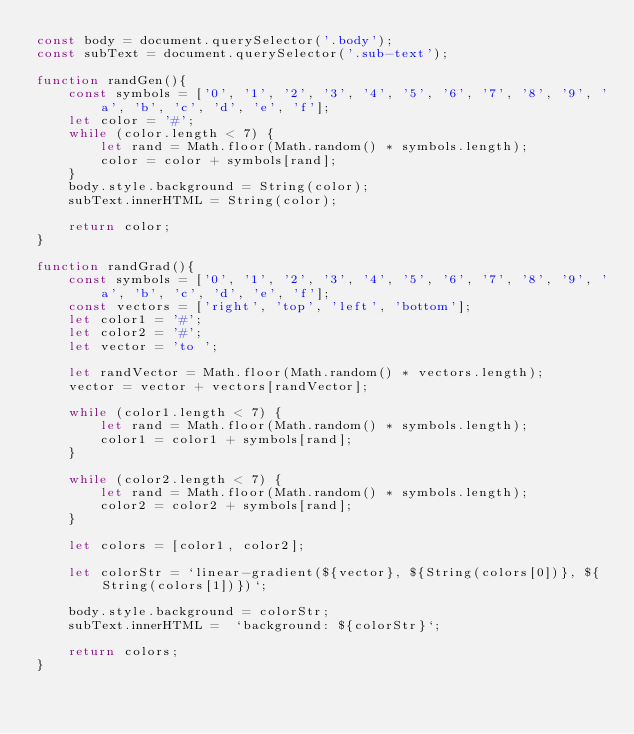<code> <loc_0><loc_0><loc_500><loc_500><_JavaScript_>const body = document.querySelector('.body');
const subText = document.querySelector('.sub-text');

function randGen(){
    const symbols = ['0', '1', '2', '3', '4', '5', '6', '7', '8', '9', 'a', 'b', 'c', 'd', 'e', 'f'];
    let color = '#';
    while (color.length < 7) {
        let rand = Math.floor(Math.random() * symbols.length);
        color = color + symbols[rand];
    }
    body.style.background = String(color);
    subText.innerHTML = String(color);

    return color;
}

function randGrad(){
    const symbols = ['0', '1', '2', '3', '4', '5', '6', '7', '8', '9', 'a', 'b', 'c', 'd', 'e', 'f'];
    const vectors = ['right', 'top', 'left', 'bottom'];
    let color1 = '#';
    let color2 = '#';
    let vector = 'to ';

    let randVector = Math.floor(Math.random() * vectors.length);
    vector = vector + vectors[randVector];

    while (color1.length < 7) {
        let rand = Math.floor(Math.random() * symbols.length);
        color1 = color1 + symbols[rand];
    }

    while (color2.length < 7) {
        let rand = Math.floor(Math.random() * symbols.length);
        color2 = color2 + symbols[rand];
    }

    let colors = [color1, color2];

    let colorStr = `linear-gradient(${vector}, ${String(colors[0])}, ${String(colors[1])})`;

    body.style.background = colorStr;
    subText.innerHTML =  `background: ${colorStr}`;

    return colors;
}</code> 